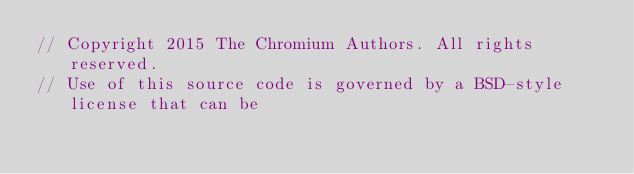Convert code to text. <code><loc_0><loc_0><loc_500><loc_500><_ObjectiveC_>// Copyright 2015 The Chromium Authors. All rights reserved.
// Use of this source code is governed by a BSD-style license that can be</code> 